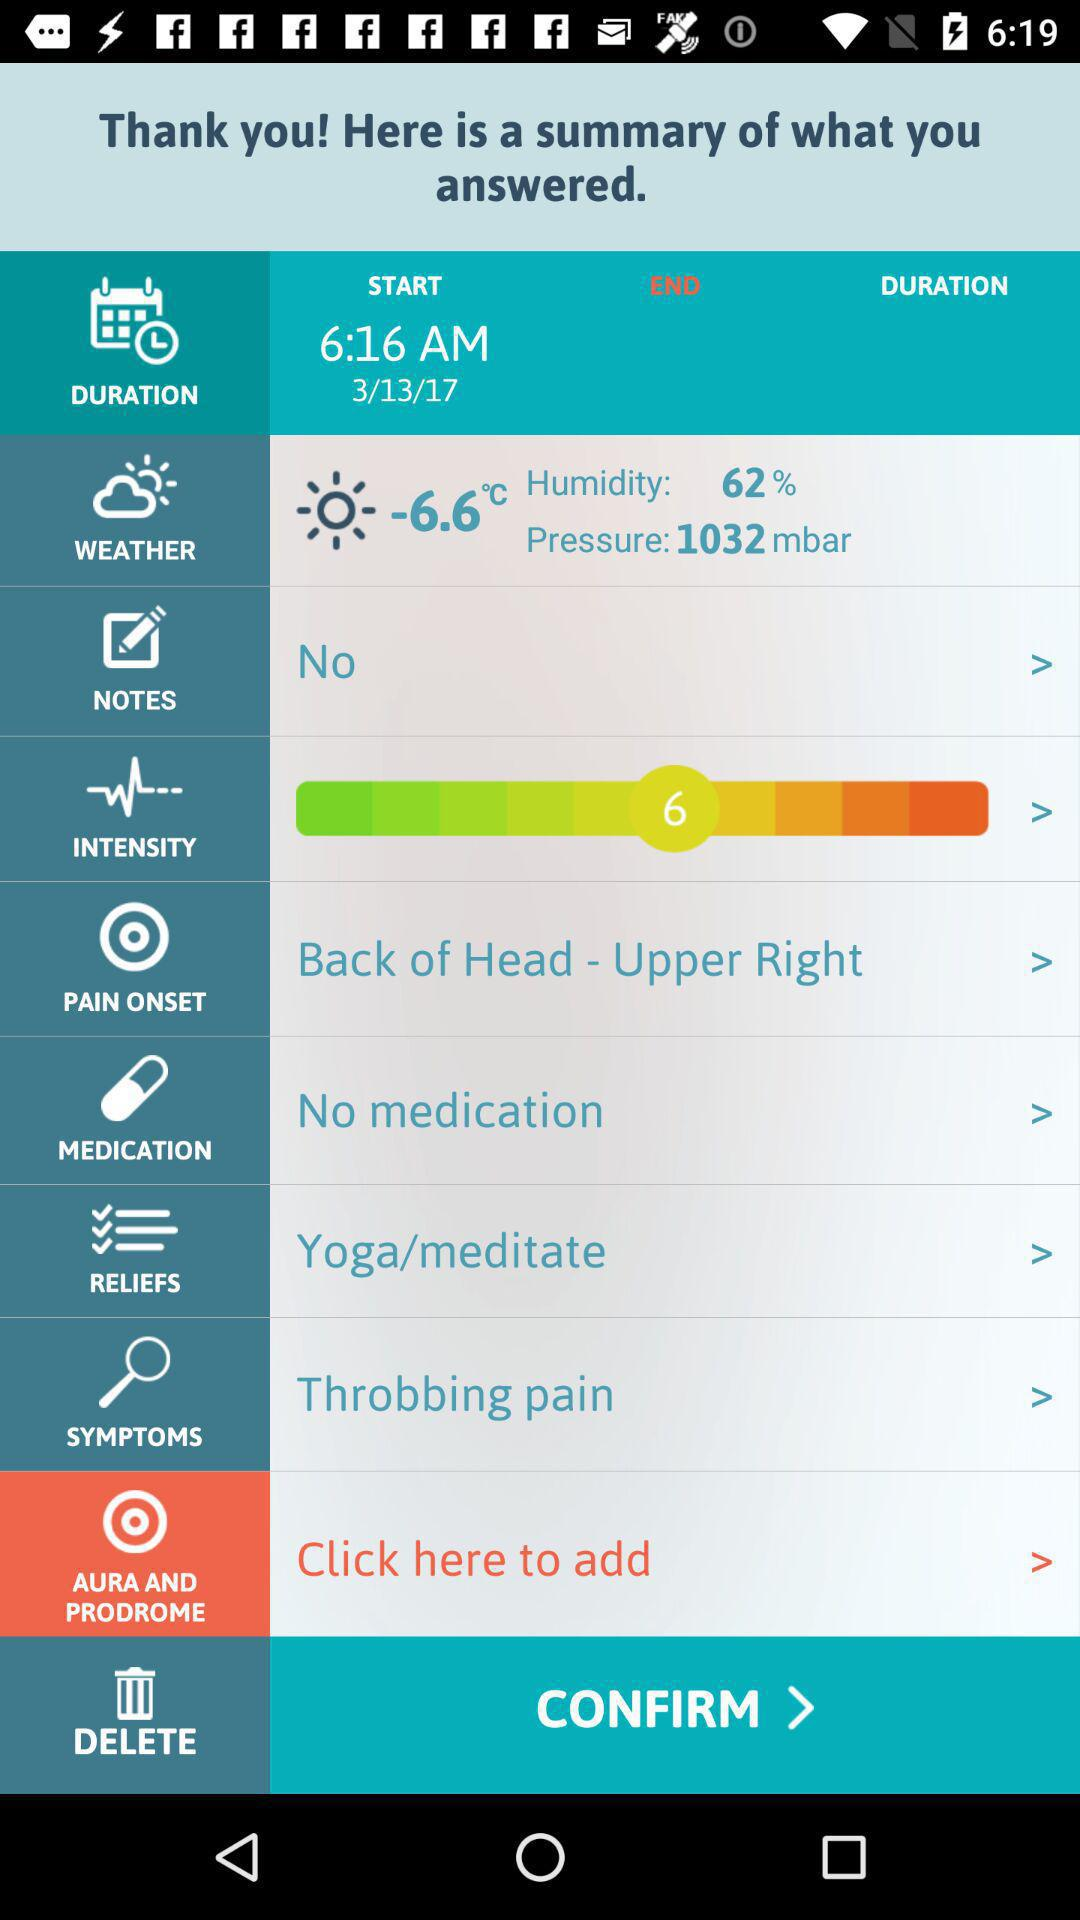What is the pressure? The pressure is 1032 mbar. 